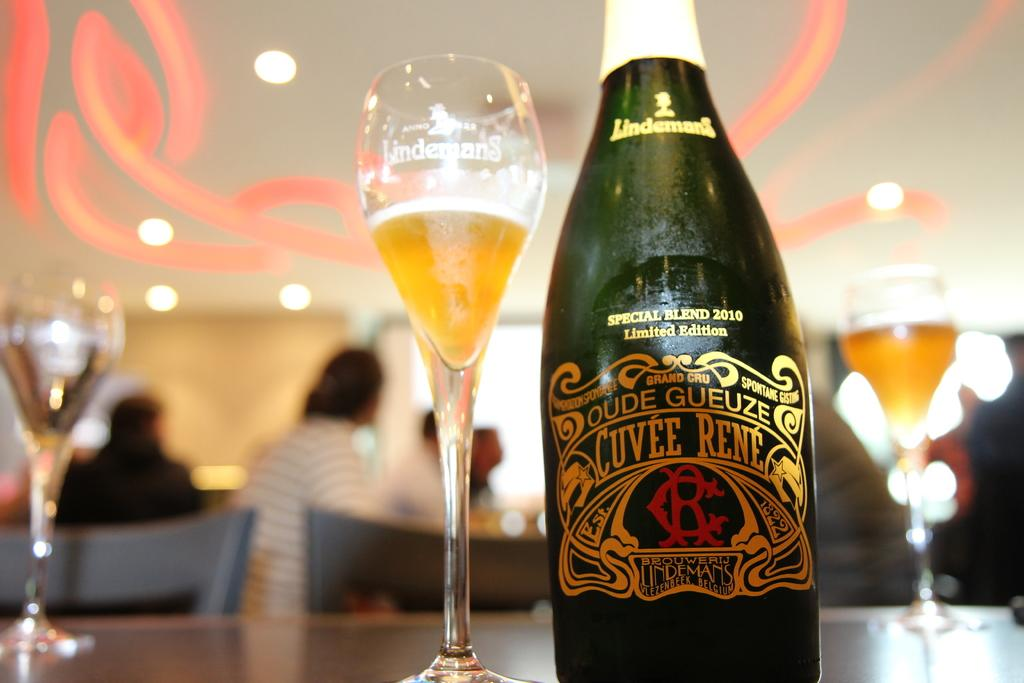<image>
Write a terse but informative summary of the picture. A bottle of Cuvee Rene says it is a special blend. 